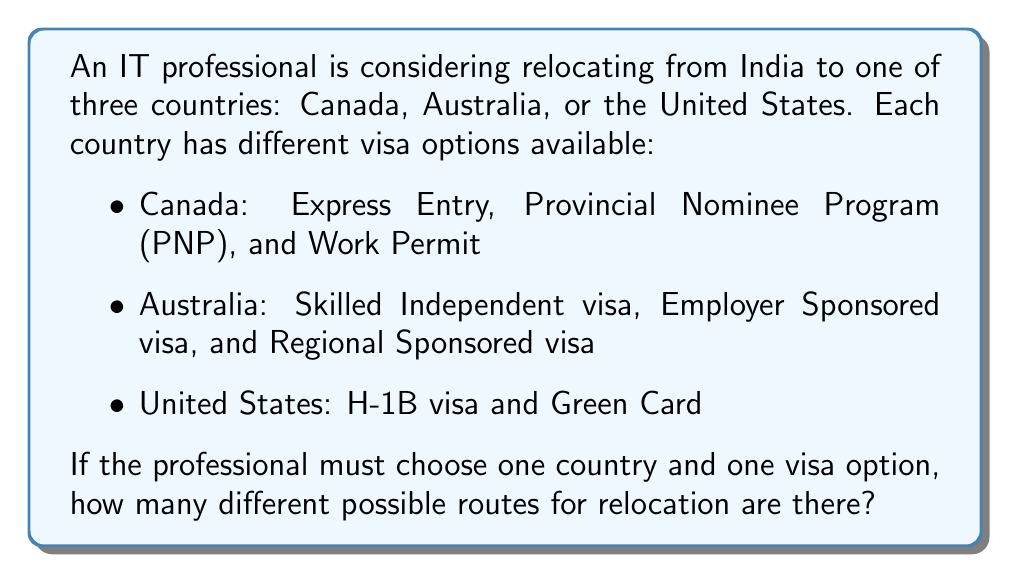Provide a solution to this math problem. Let's approach this step-by-step:

1) First, we need to identify the number of choices for each decision:
   - Number of countries: 3 (Canada, Australia, United States)
   - Number of visa options for each country:
     Canada: 3
     Australia: 3
     United States: 2

2) For each country, we need to multiply the number of countries by the number of visa options for that country:

   Canada: $1 \times 3 = 3$ options
   Australia: $1 \times 3 = 3$ options
   United States: $1 \times 2 = 2$ options

3) The total number of possible routes is the sum of all these options:

   $$\text{Total routes} = 3 + 3 + 2 = 8$$

This problem is an application of the addition principle in combinatorics. When we have separate cases (in this instance, different countries) and we want to know the total number of possibilities across all cases, we add the number of possibilities for each case.
Answer: 8 routes 